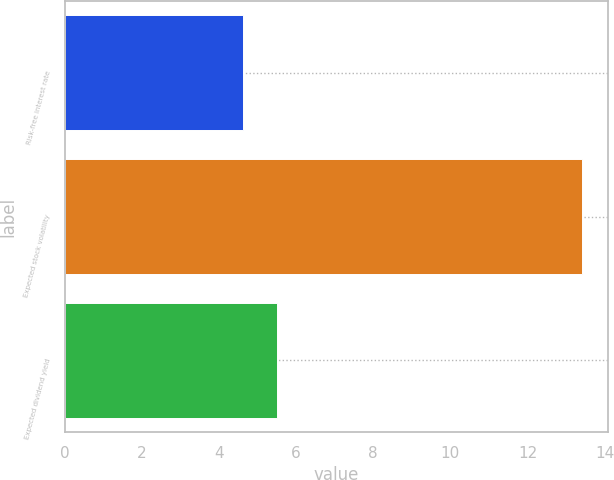Convert chart. <chart><loc_0><loc_0><loc_500><loc_500><bar_chart><fcel>Risk-free interest rate<fcel>Expected stock volatility<fcel>Expected dividend yield<nl><fcel>4.62<fcel>13.41<fcel>5.5<nl></chart> 